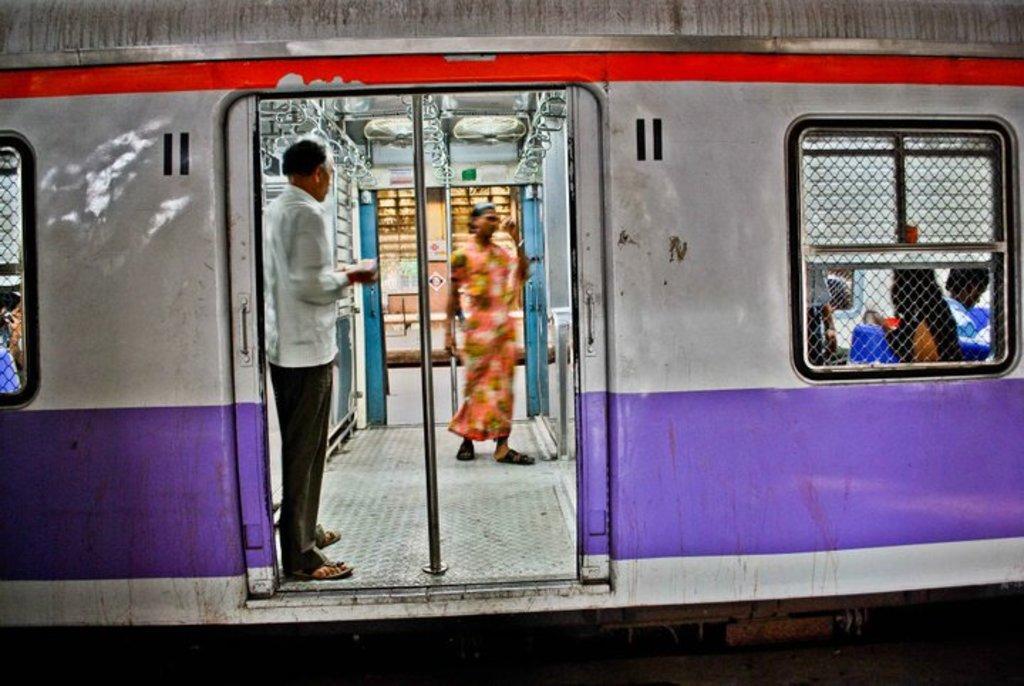Can you describe this image briefly? In this picture we can see a train, there are two persons standing in the middle, on the right side we can see a window, from the window we can see some people, there are handles and rods in the middle. 